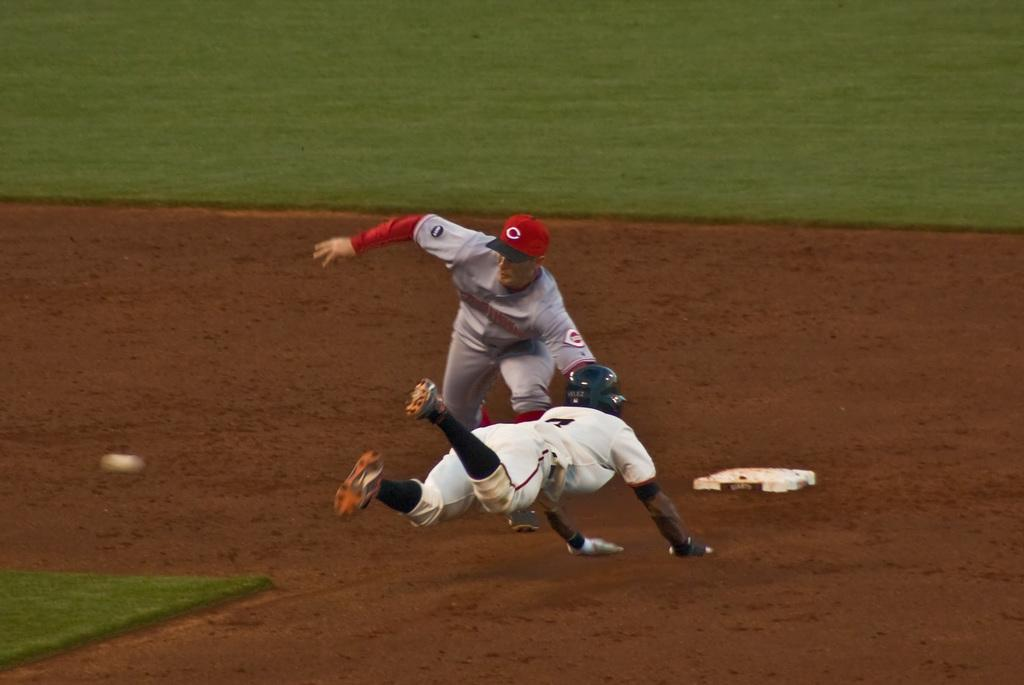How many people are present in the image? There are two people on the ground in the image. What else can be seen in the image besides the people? There are objects visible in the image. What type of natural environment is visible in the background? There is grass in the background of the image. What type of lettuce is being used as a shade in the image? There is no lettuce present in the image, nor is there any shade being used. 